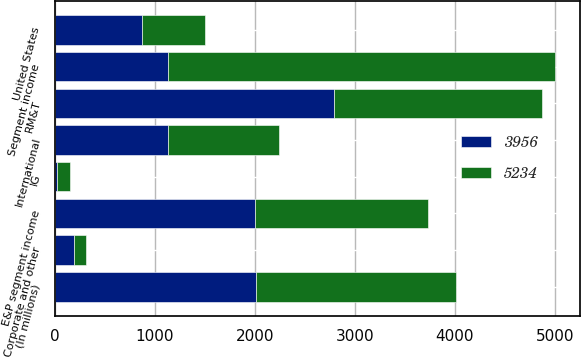<chart> <loc_0><loc_0><loc_500><loc_500><stacked_bar_chart><ecel><fcel>(In millions)<fcel>United States<fcel>International<fcel>E&P segment income<fcel>RM&T<fcel>IG<fcel>Segment income<fcel>Corporate and other<nl><fcel>5234<fcel>2007<fcel>623<fcel>1106<fcel>1729<fcel>2077<fcel>132<fcel>3875<fcel>122<nl><fcel>3956<fcel>2006<fcel>873<fcel>1130<fcel>2003<fcel>2795<fcel>16<fcel>1130<fcel>190<nl></chart> 